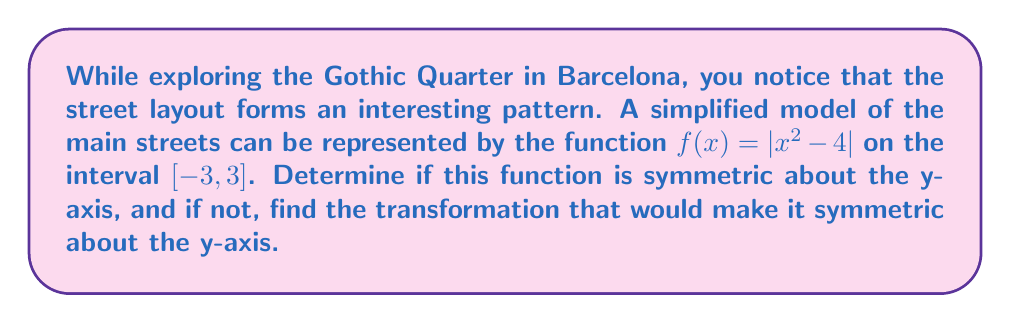Give your solution to this math problem. To determine if the function $f(x) = |x^2 - 4|$ is symmetric about the y-axis, we need to check if $f(-x) = f(x)$ for all $x$ in the given interval.

1. Let's evaluate $f(-x)$:
   $f(-x) = |(-x)^2 - 4| = |x^2 - 4|$

2. We can see that $f(-x) = f(x)$ for all $x$, which means the function is already symmetric about the y-axis.

To visualize this symmetry, we can plot the function:

[asy]
import graph;
size(200,200);
real f(real x) {return abs(x^2 - 4);}
draw(graph(f,-3,3));
draw((-3,0)--(3,0),arrow=Arrow());
draw((0,-1)--(0,5),arrow=Arrow());
label("x",(3,0),E);
label("y",(0,5),N);
[/asy]

The graph clearly shows symmetry about the y-axis. This means that the simplified model of the Gothic Quarter's main streets exhibits a mirror-like quality when reflected across the central north-south axis.

Since the function is already symmetric about the y-axis, no transformation is needed to make it symmetric.
Answer: The function $f(x) = |x^2 - 4|$ is already symmetric about the y-axis. No transformation is needed. 